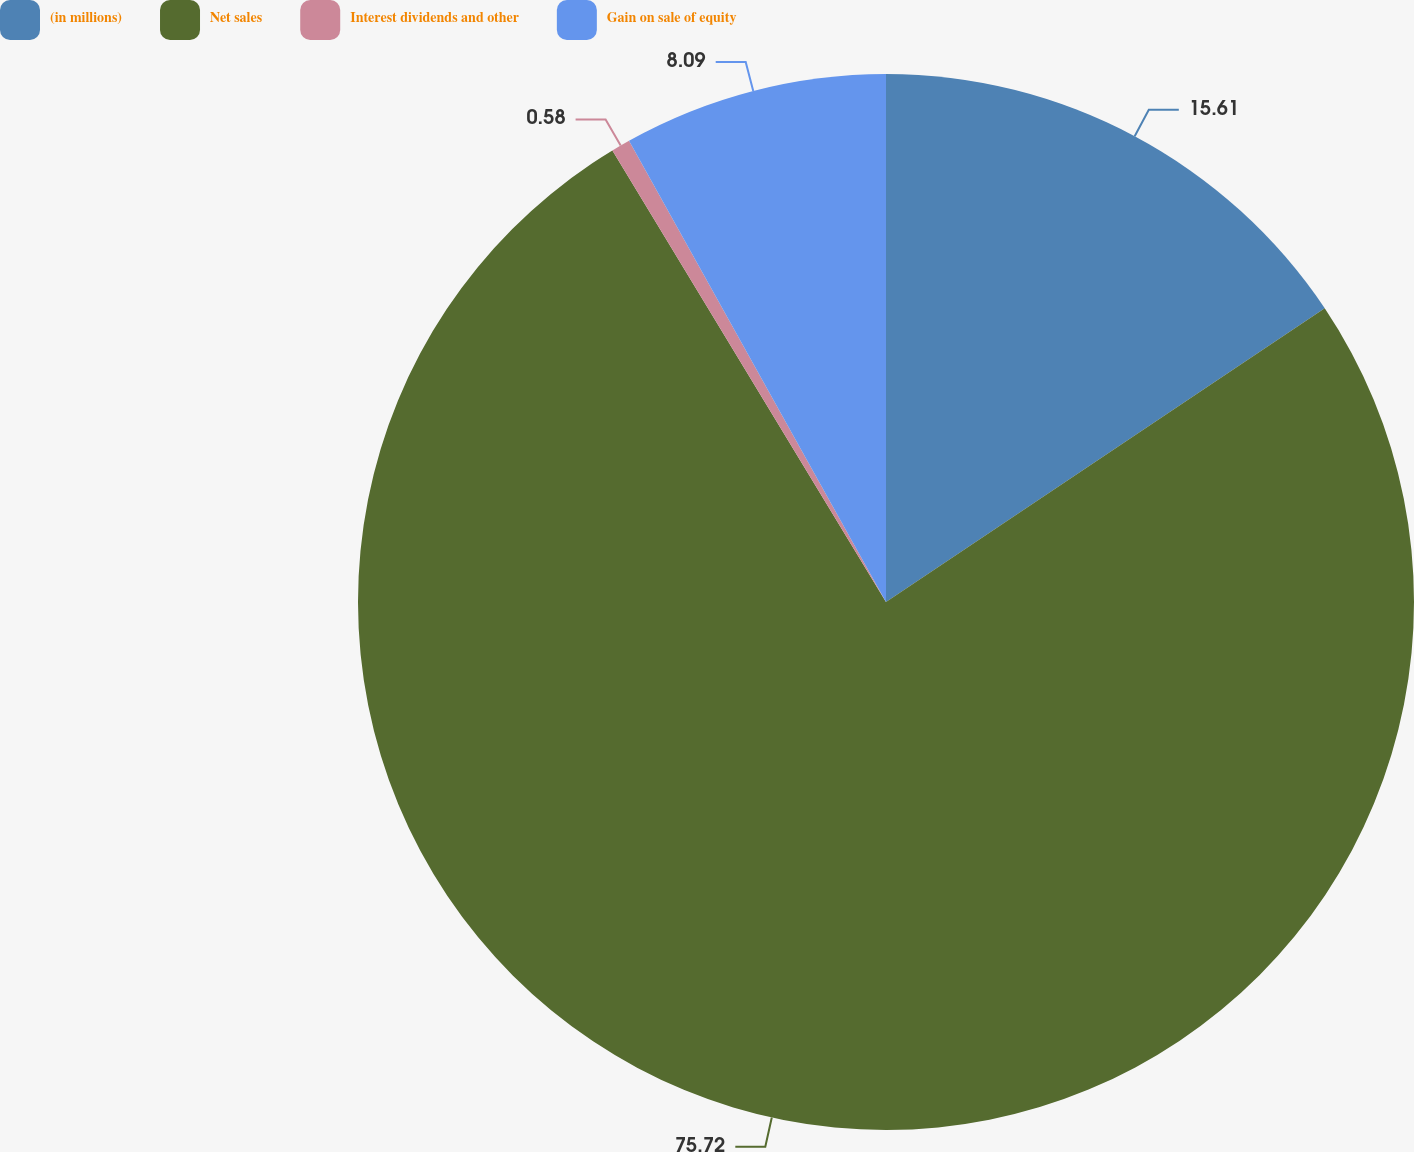Convert chart to OTSL. <chart><loc_0><loc_0><loc_500><loc_500><pie_chart><fcel>(in millions)<fcel>Net sales<fcel>Interest dividends and other<fcel>Gain on sale of equity<nl><fcel>15.61%<fcel>75.72%<fcel>0.58%<fcel>8.09%<nl></chart> 